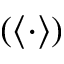Convert formula to latex. <formula><loc_0><loc_0><loc_500><loc_500>\left ( \langle \cdot \rangle \right )</formula> 